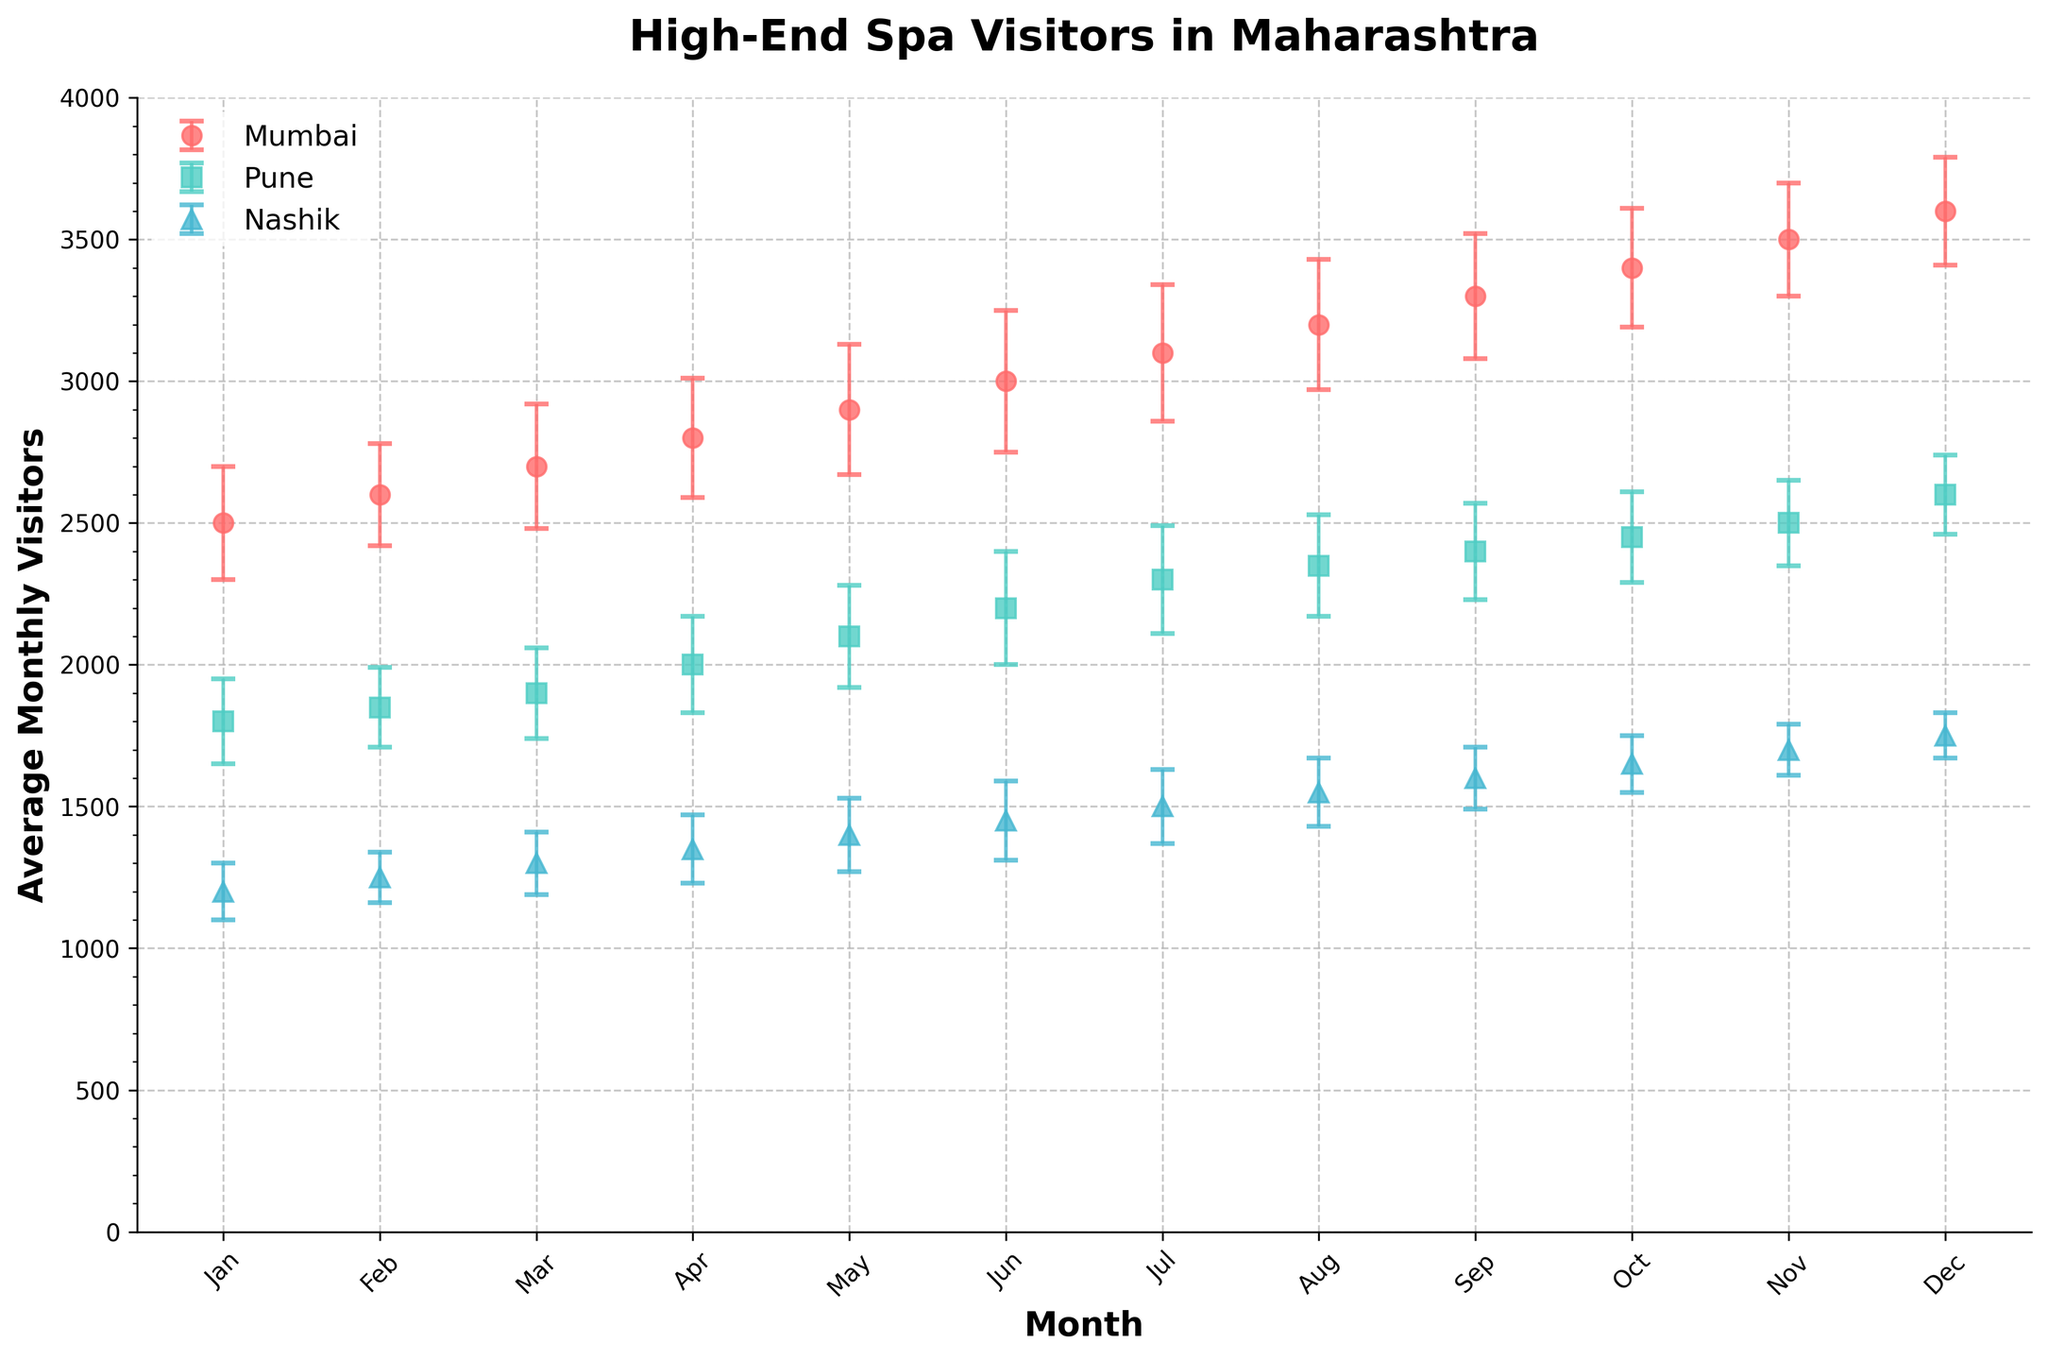What is the title of the figure? The title of the figure can be found at the top center of the plot. It is usually a brief description of what the plot represents.
Answer: High-End Spa Visitors in Maharashtra Which month shows the highest average number of visitors in Mumbai? To find the month with the highest average number of visitors, locate the peak point in the Mumbai data line on the scatter plot and check the corresponding month on the x-axis.
Answer: December What is the range of average monthly visitors for Pune? To determine the range, identify the highest and lowest points for Pune on the y-axis and calculate the difference. The lowest is 1800, and the highest is 2600. So, the range is 2600 - 1800.
Answer: 800 During which month is the error margin smallest for Nashik? Check the error bars for each month in Nashik and find the month where the bars are shortest.
Answer: December Which location has the least variation in visitor numbers throughout the year? Compare the error margins (heights of error bars) across all months for all locations. The location with the smallest overall error bars has the least variation.
Answer: Nashik In which month does Pune surpass 2000 average visitors? Check the points on the y-axis for Pune and find the first month where the average visitor number exceeds 2000.
Answer: April For which months do Mumbai and Pune have approximately equal average visitors? Look for the points where the plots for Mumbai and Pune are close to each other in terms of the y-axis values.
Answer: None Which location shows a steady increase in visitor numbers over the months? Observe the general trend of the points in each location's series. The location with points that consistently rise month by month indicates a steady increase.
Answer: All Locations Comparing Mumbai and Nashik, in which month is the difference in average visitors the largest? Calculate the difference in average visitors between Mumbai and Nashik for each month and find the month with the largest difference.
Answer: December What can you infer about the seasonal fluctuations in visitor numbers for all locations? Look at the overall trends and error bars for all locations. Compare these to determine whether there are any common seasonal patterns or distinct differences.
Answer: All locations show an increase in visitors towards the end of the year, with varying magnitudes of seasonal fluctuations 